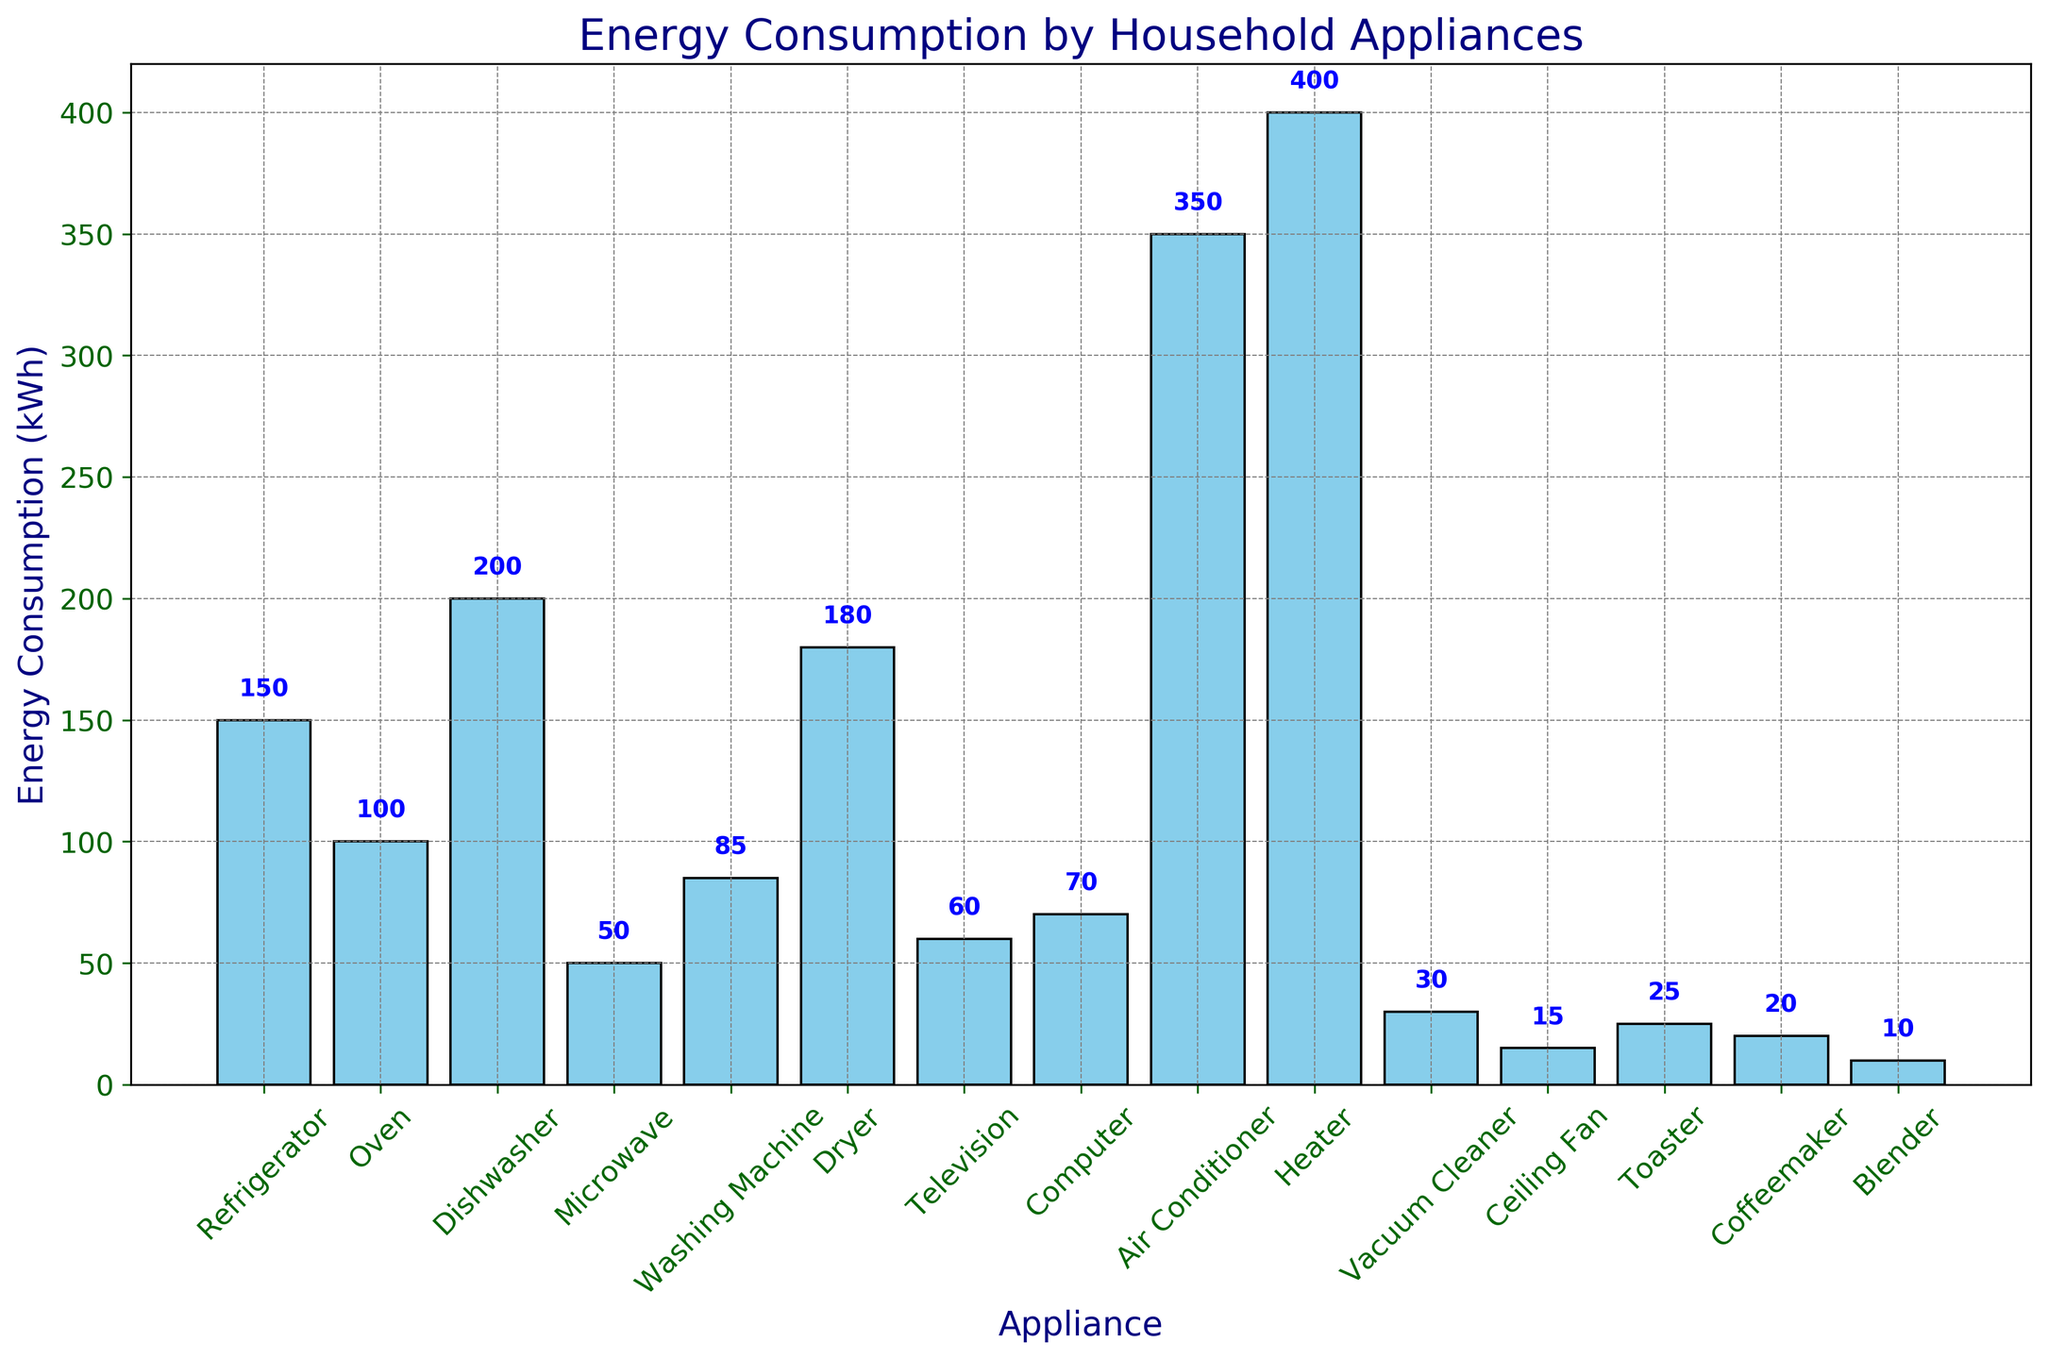Which appliance has the highest energy consumption? The bar for the appliance with the highest energy consumption is the tallest. From the figure, the tallest bar belongs to the Heater.
Answer: Heater What is the energy consumption difference between the Heater and the Refrigerator? The energy consumption of the Heater is 400 kWh, and for the Refrigerator, it is 150 kWh. The difference is 400 - 150 = 250 kWh.
Answer: 250 kWh Which appliances have an energy consumption greater than 300 kWh? The bars taller than the 300 kWh mark represent appliances with energy consumption above 300 kWh. From the figure, the Heater and Air Conditioner have such values.
Answer: Heater, Air Conditioner How many appliances consume less than 50 kWh of energy? Count the number of bars that are shorter than the 50 kWh mark. The appliances are Ceiling Fan, Toaster, Coffeemaker, and Blender. There are 4 such appliances.
Answer: 4 What’s the average energy consumption of the Refrigerator, Oven, and Dishwasher? To find the average, sum the energy consumption of these appliances: 150 kWh (Refrigerator) + 100 kWh (Oven) + 200 kWh (Dishwasher) = 450 kWh. Divide by the number of appliances: 450 / 3 = 150 kWh.
Answer: 150 kWh Is there any appliance that consumes exactly 60 kWh? Look for a bar that reaches exactly 60 kWh. The Television consumes 60 kWh.
Answer: Television Compare the energy consumption of the Dishwasher and Dryer. Which one consumes more energy? Compare the heights of the Dishwasher (200 kWh) and Dryer (180 kWh). The higher bar belongs to the Dishwasher.
Answer: Dishwasher Are there more appliances with energy consumption above or below 100 kWh? Count the number of appliances with consumption above 100 kWh and below 100 kWh. Above 100 kWh: Refrigerator, Dishwasher, Dryer, Air Conditioner, Heater = 5. Below 100 kWh: Oven, Microwave, Washing Machine, Television, Computer, Vacuum Cleaner, Ceiling Fan, Toaster, Coffeemaker, Blender = 10. There are more below 100 kWh.
Answer: Below 100 kWh What is the total energy consumption of the Washer and Dryer combined? Add the energy consumption of Washing Machine (85 kWh) and Dryer (180 kWh): 85 + 180 = 265 kWh.
Answer: 265 kWh Which appliance has the lowest energy consumption? The shortest bar indicates the appliance with the lowest energy consumption. The Blender has the shortest bar.
Answer: Blender 